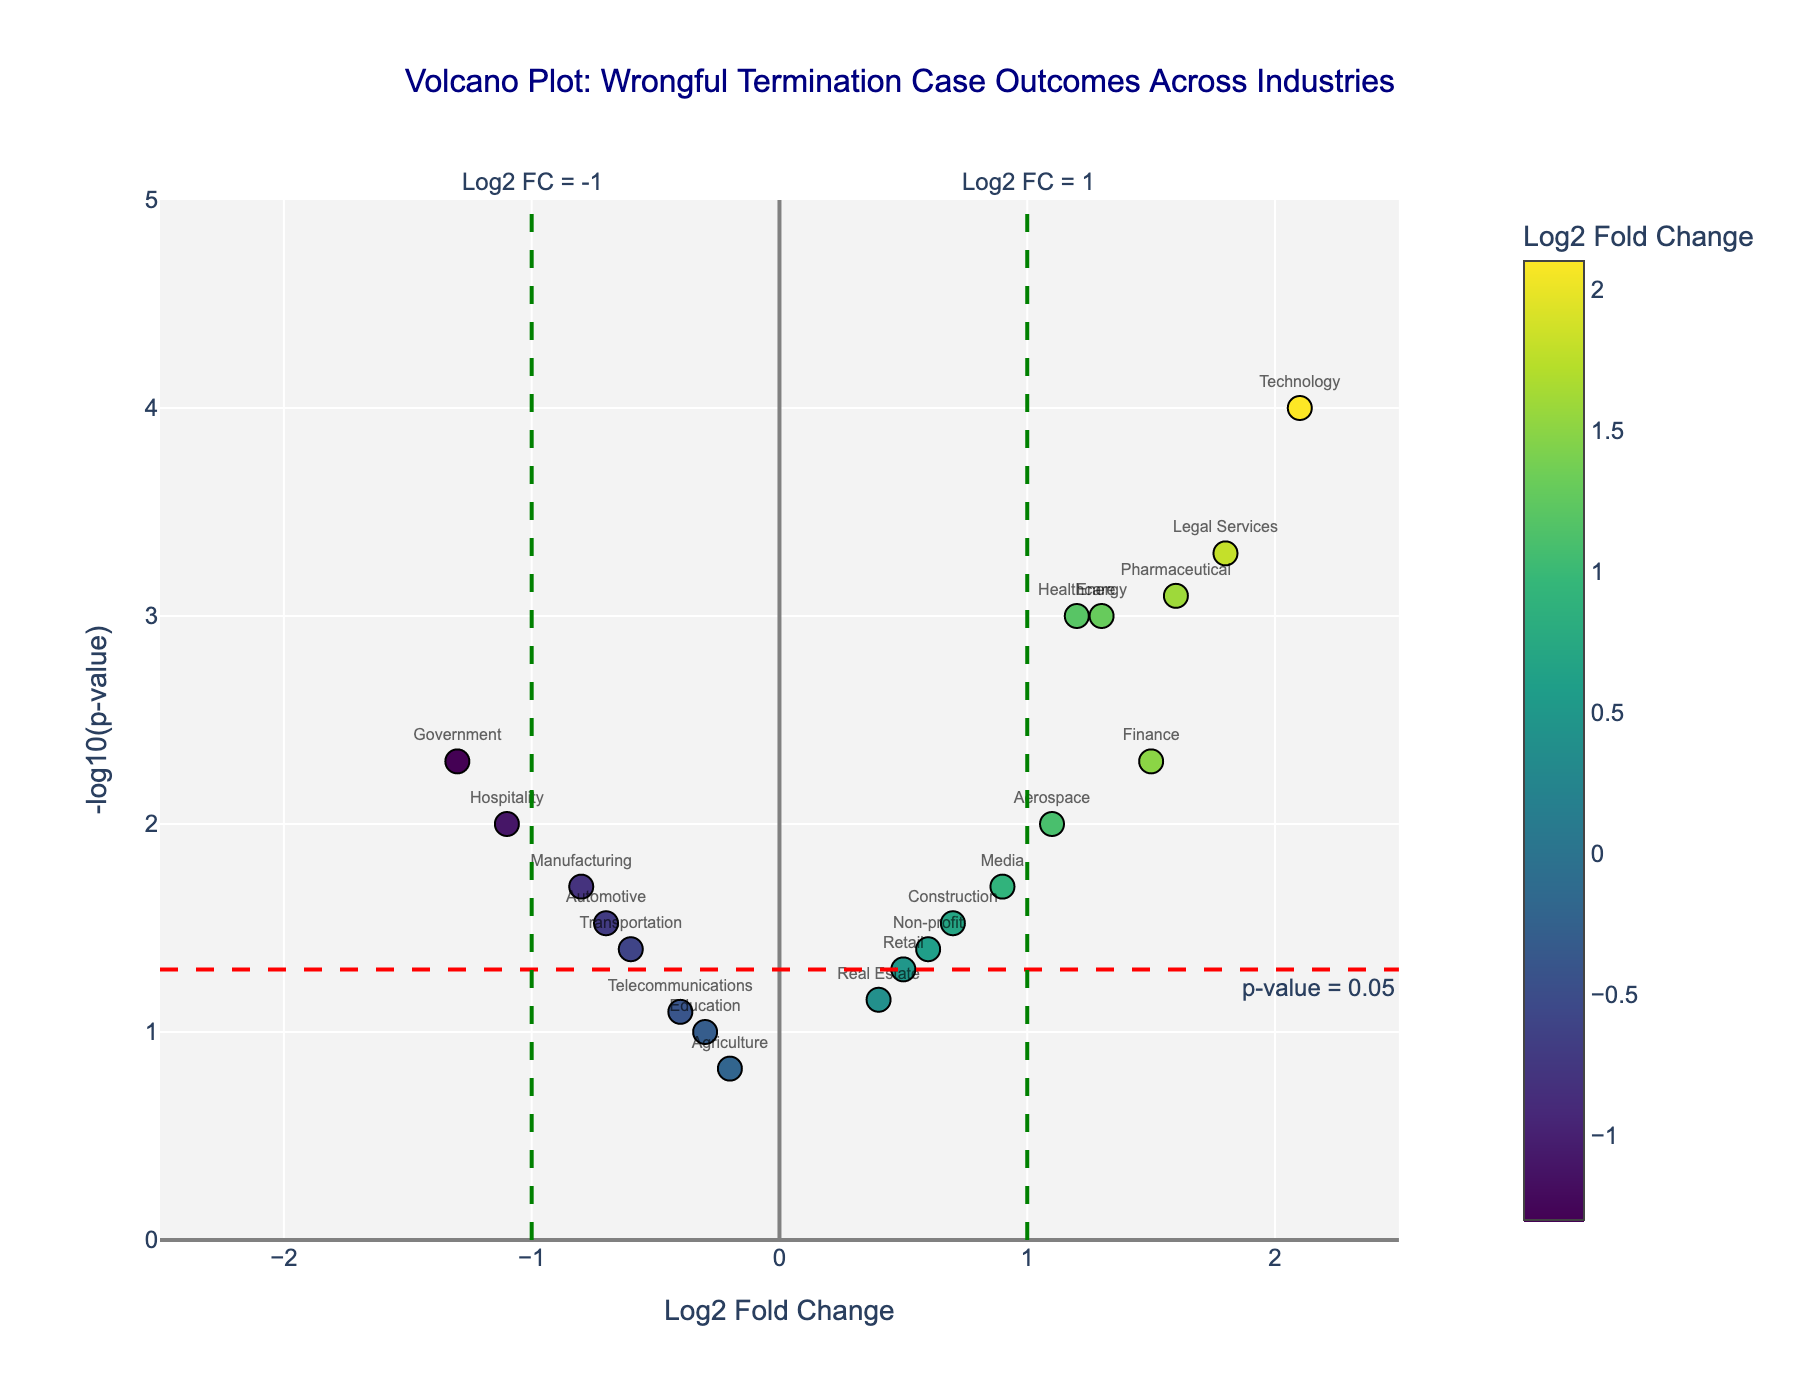How many industries are depicted in the plot? Count the number of different industries labeled in the plot.
Answer: 20 Which industry has the highest Log2 Fold Change? Identify the data point with the highest x-axis value.
Answer: Technology Which industry has the lowest p-value? Identify the data point with the highest y-axis value, as lower p-values correspond to higher -log10(p-values).
Answer: Technology How many industries have a statistically significant p-value (0.05 or lower)? Count the number of points above the red horizontal line at -log10(0.05), which represents p=0.05.
Answer: 13 Which industries have a Log2 Fold Change greater than 1 and a p-value less than 0.05? Look for points to the right of the green vertical line at Log2 Fold Change = 1 and above the red horizontal line at -log10(0.05).
Answer: Technology, Finance, Legal Services, Energy, Pharmaceutical How many industries show a negative Log2 Fold Change? Count the number of points to the left of the zero on the x-axis.
Answer: 8 What is the Log2 Fold Change and p-value for the Healthcare industry? Find the data point labeled 'Healthcare' and refer to its x (Log2 Fold Change) and y (-log10(p-value)) coordinates and convert the y value back to p-value by 10^-(y coordinate).
Answer: Log2 Fold Change: 1.2, P-value: 0.001 Which industries have a Log2 Fold Change less than -1? Identify points to the left of the green vertical line at Log2 Fold Change = -1.
Answer: Hospitality, Government Compare the Log2 Fold Change and p-value between Construction and Real Estate. Locate the points labeled 'Construction' and 'Real Estate' and refer to their coordinates on the plot.
Answer: Construction: Log2 Fold Change = 0.7, p-value = 0.03; Real Estate: Log2 Fold Change = 0.4, p-value = 0.07 In which quadrant of the plot does the Education industry fall, considering positive or negative Log2 Fold Change and p-value threshold of 0.05? Identify the position of the 'Education' point on the plot relative to the axes and threshold lines: top-right, top-left, bottom-right, or bottom-left.
Answer: Bottom-left 